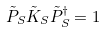<formula> <loc_0><loc_0><loc_500><loc_500>\tilde { P } _ { S } \tilde { K } _ { S } \tilde { P } _ { S } ^ { \dag } = 1</formula> 